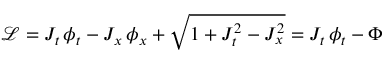<formula> <loc_0><loc_0><loc_500><loc_500>\mathcal { L } = J _ { t } \, \phi _ { t } - J _ { x } \, \phi _ { x } + \sqrt { 1 + J _ { t } ^ { 2 } - J _ { x } ^ { 2 } } = J _ { t } \, \phi _ { t } - \Phi</formula> 